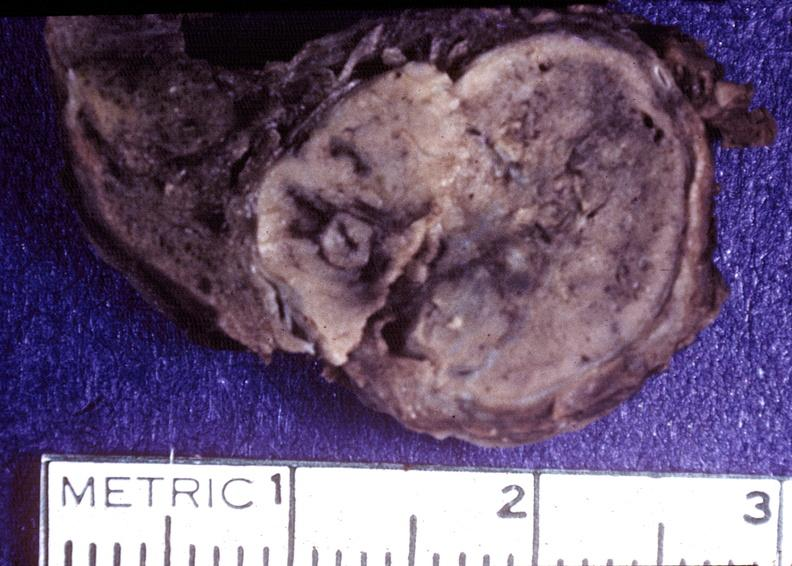s endocrine present?
Answer the question using a single word or phrase. Yes 